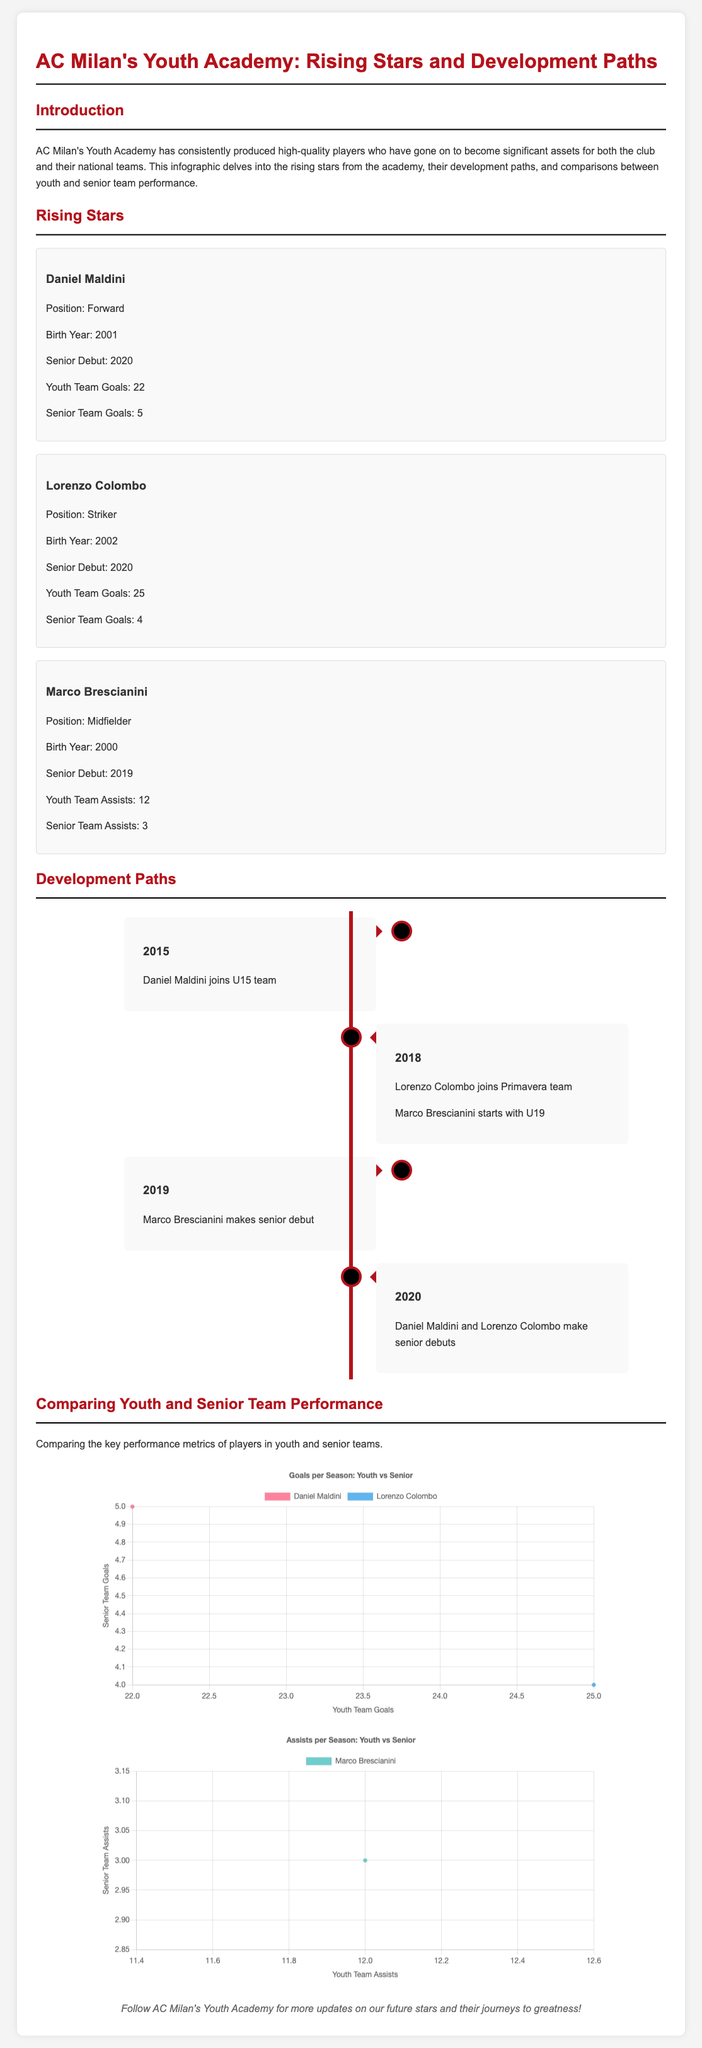What is the birth year of Daniel Maldini? The document states that Daniel Maldini was born in 2001.
Answer: 2001 How many goals did Lorenzo Colombo score in the youth team? The youth team goals for Lorenzo Colombo mentioned in the document are 25.
Answer: 25 In which year did Marco Brescianini make his senior debut? The document indicates that Marco Brescianini made his senior debut in 2019.
Answer: 2019 What is the title of the first section in the document? The first section is titled "Introduction" according to the document structure.
Answer: Introduction What is the total number of assists by Marco Brescianini in the youth team? The document mentions that Marco Brescianini had 12 assists in the youth team.
Answer: 12 Which player has the most youth team goals? Based on the data provided, Lorenzo Colombo has the most youth team goals with 25.
Answer: Lorenzo Colombo In what year did Daniel Maldini and Lorenzo Colombo make their senior debuts? The document states that both players made their senior debuts in 2020.
Answer: 2020 What type of chart is used to compare youth and senior team goals? The document specifies that a scatter chart is used for this comparison.
Answer: Scatter chart How many assists did Marco Brescianini achieve in the senior team? According to the document, Marco Brescianini achieved 3 assists in the senior team.
Answer: 3 